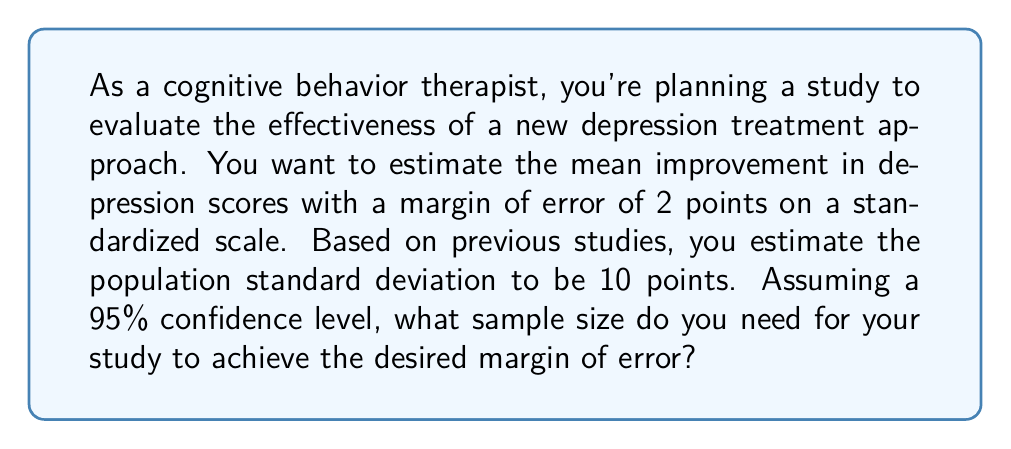Provide a solution to this math problem. To determine the required sample size, we'll use the formula for margin of error and solve for n (sample size). Let's break it down step-by-step:

1) The formula for margin of error (E) is:

   $$E = z_{\alpha/2} \cdot \frac{\sigma}{\sqrt{n}}$$

   Where:
   - $z_{\alpha/2}$ is the critical value (1.96 for 95% confidence level)
   - $\sigma$ is the population standard deviation
   - $n$ is the sample size

2) We're given:
   - E = 2 (desired margin of error)
   - $\sigma$ = 10 (estimated population standard deviation)
   - Confidence level = 95%, so $z_{\alpha/2}$ = 1.96

3) Let's substitute these values into the formula:

   $$2 = 1.96 \cdot \frac{10}{\sqrt{n}}$$

4) Now, let's solve for n:
   
   $$\sqrt{n} = 1.96 \cdot \frac{10}{2} = 9.8$$

   $$n = (9.8)^2 = 96.04$$

5) Since we can't have a fractional sample size, we round up to the nearest whole number:

   $$n = 97$$

Therefore, you need a sample size of at least 97 participants to achieve a margin of error of 2 points with 95% confidence.
Answer: 97 participants 